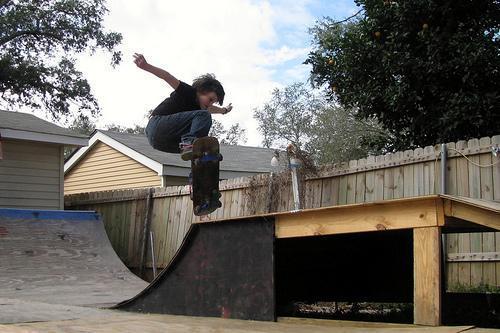How many people are in the photo?
Give a very brief answer. 1. How many children are in the image on a skateboard?
Give a very brief answer. 1. 